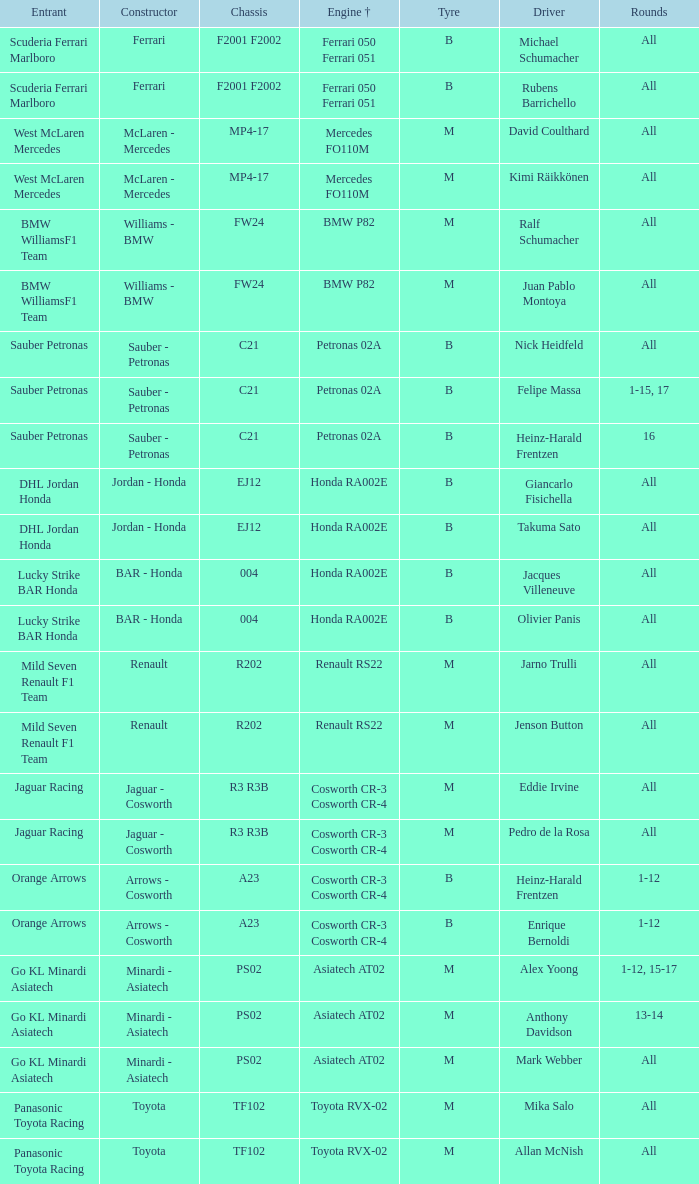What is the chassis when the tyre is b, the engine is ferrari 050 ferrari 051 and the driver is rubens barrichello? F2001 F2002. 